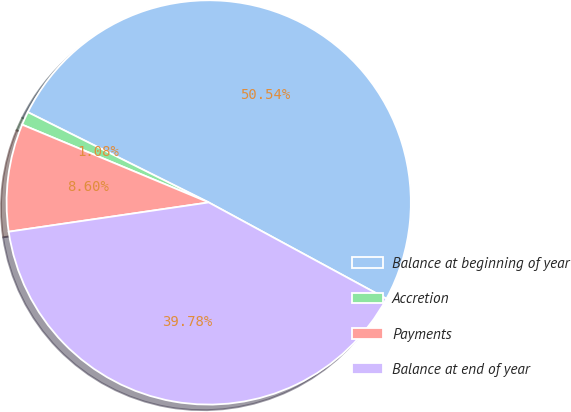Convert chart. <chart><loc_0><loc_0><loc_500><loc_500><pie_chart><fcel>Balance at beginning of year<fcel>Accretion<fcel>Payments<fcel>Balance at end of year<nl><fcel>50.54%<fcel>1.08%<fcel>8.6%<fcel>39.78%<nl></chart> 